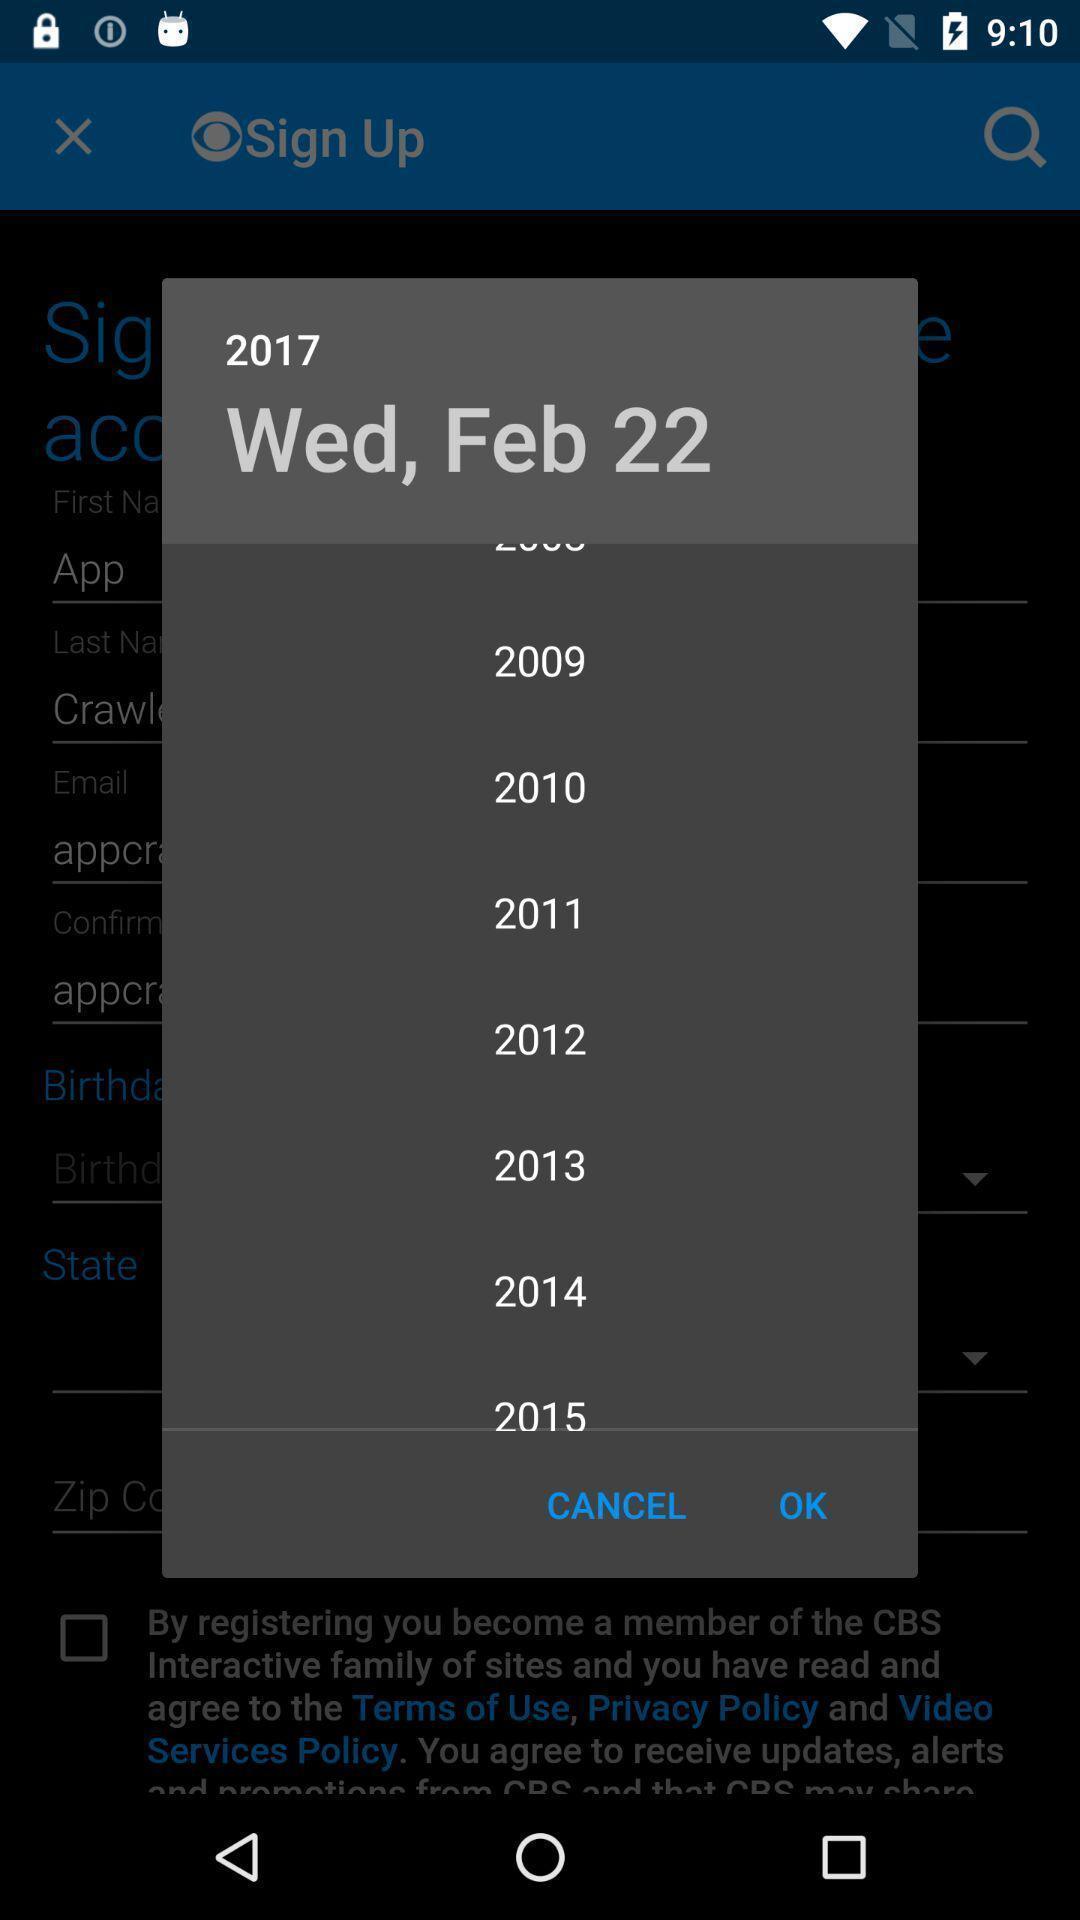What can you discern from this picture? Popup of a calendar. 